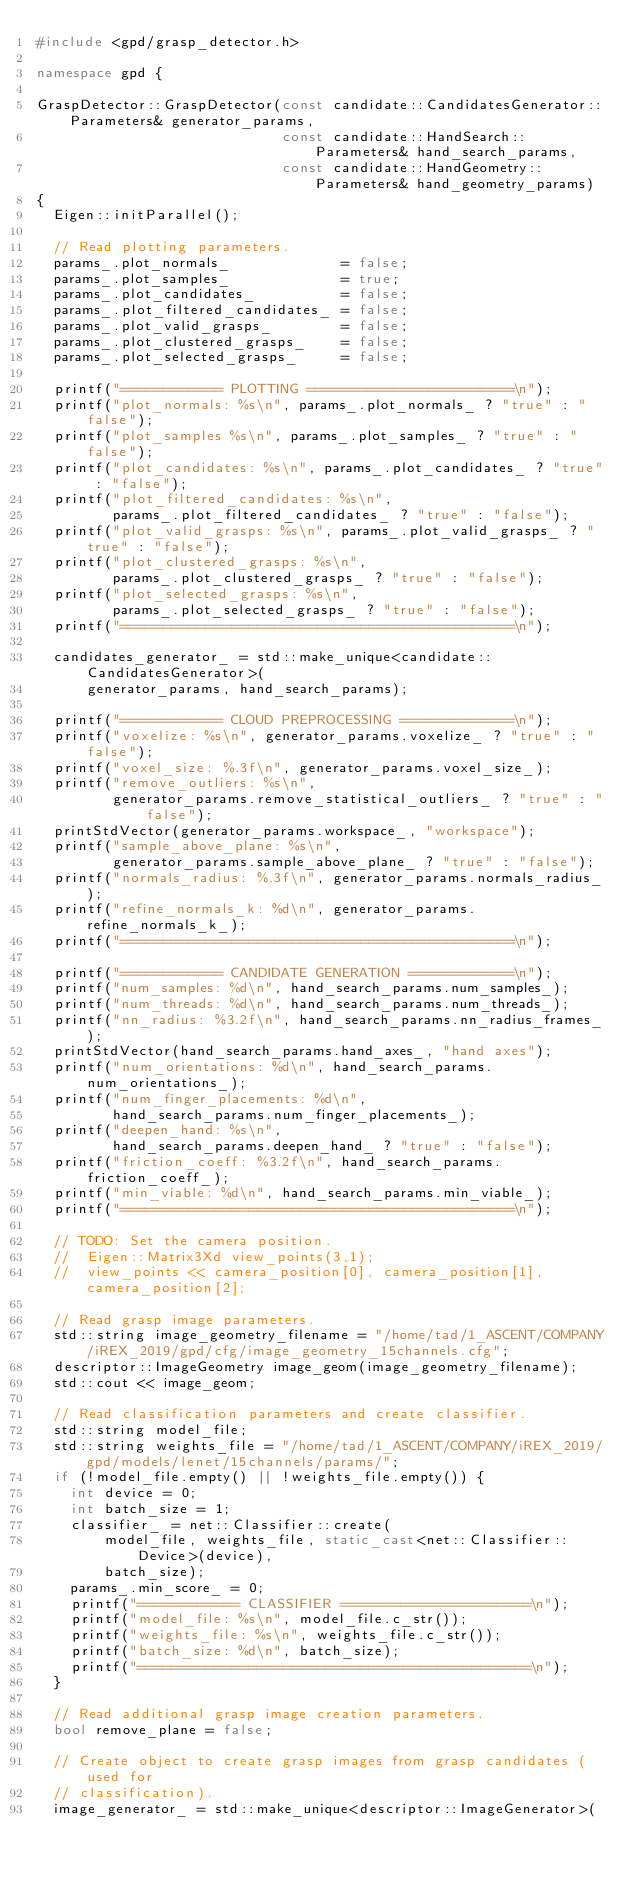<code> <loc_0><loc_0><loc_500><loc_500><_C++_>#include <gpd/grasp_detector.h>

namespace gpd {

GraspDetector::GraspDetector(const candidate::CandidatesGenerator::Parameters& generator_params,
                             const candidate::HandSearch::Parameters& hand_search_params,
                             const candidate::HandGeometry::Parameters& hand_geometry_params)
{
  Eigen::initParallel();

  // Read plotting parameters.
  params_.plot_normals_             = false;
  params_.plot_samples_             = true;
  params_.plot_candidates_          = false;
  params_.plot_filtered_candidates_ = false;
  params_.plot_valid_grasps_        = false;
  params_.plot_clustered_grasps_    = false;
  params_.plot_selected_grasps_     = false;

  printf("============ PLOTTING ========================\n");
  printf("plot_normals: %s\n", params_.plot_normals_ ? "true" : "false");
  printf("plot_samples %s\n", params_.plot_samples_ ? "true" : "false");
  printf("plot_candidates: %s\n", params_.plot_candidates_ ? "true" : "false");
  printf("plot_filtered_candidates: %s\n",
         params_.plot_filtered_candidates_ ? "true" : "false");
  printf("plot_valid_grasps: %s\n", params_.plot_valid_grasps_ ? "true" : "false");
  printf("plot_clustered_grasps: %s\n",
         params_.plot_clustered_grasps_ ? "true" : "false");
  printf("plot_selected_grasps: %s\n",
         params_.plot_selected_grasps_ ? "true" : "false");
  printf("==============================================\n");

  candidates_generator_ = std::make_unique<candidate::CandidatesGenerator>(
      generator_params, hand_search_params);

  printf("============ CLOUD PREPROCESSING =============\n");
  printf("voxelize: %s\n", generator_params.voxelize_ ? "true" : "false");
  printf("voxel_size: %.3f\n", generator_params.voxel_size_);
  printf("remove_outliers: %s\n",
         generator_params.remove_statistical_outliers_ ? "true" : "false");
  printStdVector(generator_params.workspace_, "workspace");
  printf("sample_above_plane: %s\n",
         generator_params.sample_above_plane_ ? "true" : "false");
  printf("normals_radius: %.3f\n", generator_params.normals_radius_);
  printf("refine_normals_k: %d\n", generator_params.refine_normals_k_);
  printf("==============================================\n");

  printf("============ CANDIDATE GENERATION ============\n");
  printf("num_samples: %d\n", hand_search_params.num_samples_);
  printf("num_threads: %d\n", hand_search_params.num_threads_);
  printf("nn_radius: %3.2f\n", hand_search_params.nn_radius_frames_);
  printStdVector(hand_search_params.hand_axes_, "hand axes");
  printf("num_orientations: %d\n", hand_search_params.num_orientations_);
  printf("num_finger_placements: %d\n",
         hand_search_params.num_finger_placements_);
  printf("deepen_hand: %s\n",
         hand_search_params.deepen_hand_ ? "true" : "false");
  printf("friction_coeff: %3.2f\n", hand_search_params.friction_coeff_);
  printf("min_viable: %d\n", hand_search_params.min_viable_);
  printf("==============================================\n");

  // TODO: Set the camera position.
  //  Eigen::Matrix3Xd view_points(3,1);
  //  view_points << camera_position[0], camera_position[1], camera_position[2];

  // Read grasp image parameters.
  std::string image_geometry_filename = "/home/tad/1_ASCENT/COMPANY/iREX_2019/gpd/cfg/image_geometry_15channels.cfg";
  descriptor::ImageGeometry image_geom(image_geometry_filename);
  std::cout << image_geom;

  // Read classification parameters and create classifier.
  std::string model_file;
  std::string weights_file = "/home/tad/1_ASCENT/COMPANY/iREX_2019/gpd/models/lenet/15channels/params/";
  if (!model_file.empty() || !weights_file.empty()) {
    int device = 0;
    int batch_size = 1;
    classifier_ = net::Classifier::create(
        model_file, weights_file, static_cast<net::Classifier::Device>(device),
        batch_size);
    params_.min_score_ = 0;
    printf("============ CLASSIFIER ======================\n");
    printf("model_file: %s\n", model_file.c_str());
    printf("weights_file: %s\n", weights_file.c_str());
    printf("batch_size: %d\n", batch_size);
    printf("==============================================\n");
  }

  // Read additional grasp image creation parameters.
  bool remove_plane = false;

  // Create object to create grasp images from grasp candidates (used for
  // classification).
  image_generator_ = std::make_unique<descriptor::ImageGenerator>(</code> 